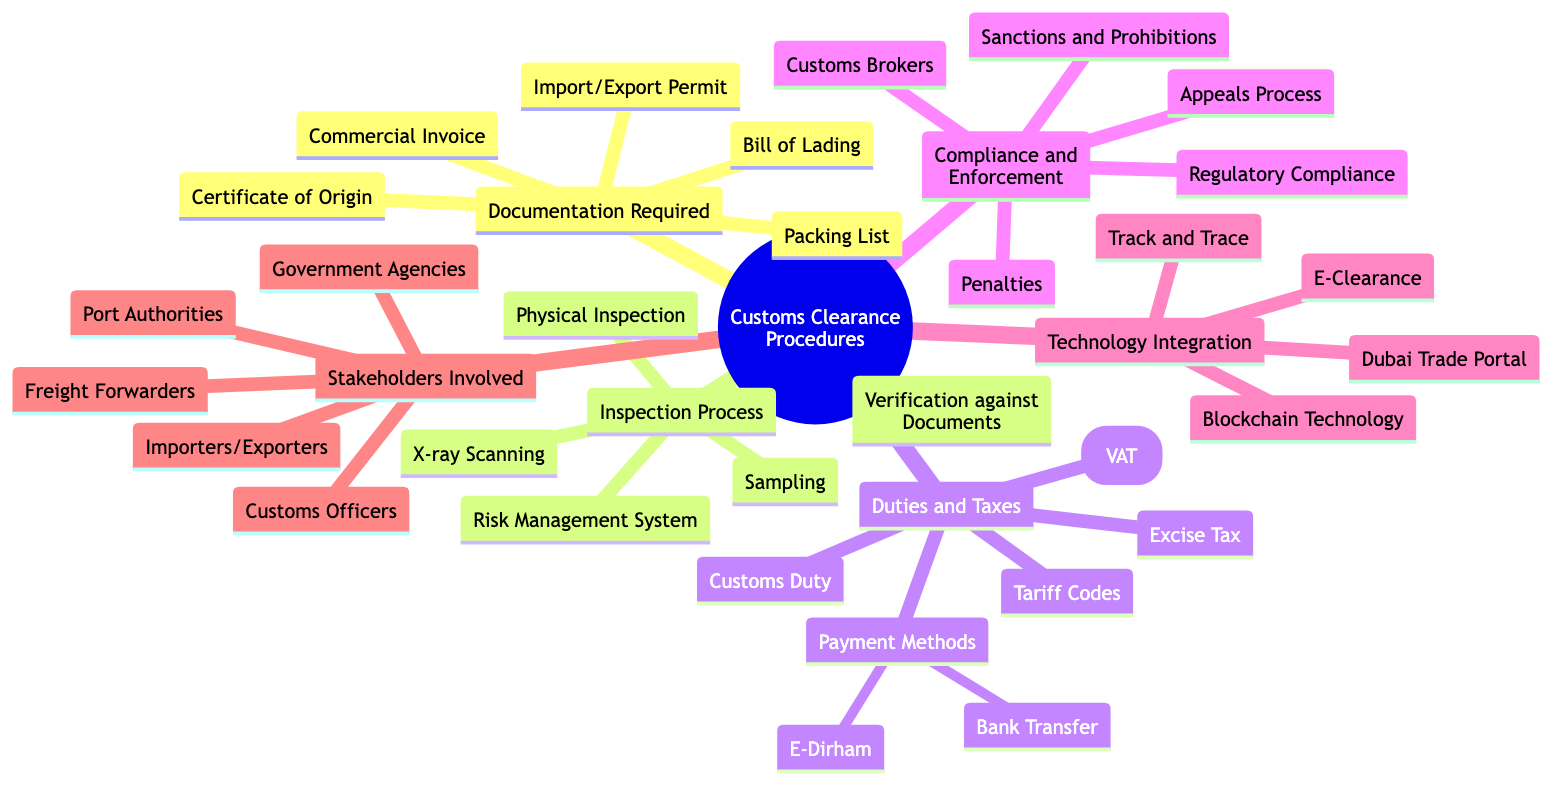What are the components under Documentation Required? The diagram lists the components under Documentation Required as Commercial Invoice, Bill of Lading, Certificate of Origin, Import/Export Permit, and Packing List. These are the key documents needed for customs clearance.
Answer: Commercial Invoice, Bill of Lading, Certificate of Origin, Import/Export Permit, Packing List How many types of inspections are listed? The Inspection Process section contains five types of inspections: Physical Inspection, X-ray Scanning, Risk Management System, Sampling, and Verification against Documents. Thus, the total count of inspection types is five.
Answer: 5 Which tax is imposed on imports by the UAE government? The diagram lists Customs Duty as the tax imposed on imports by the UAE government within the Duties and Taxes section. This is a direct reference from the diagram.
Answer: Customs Duty What is the VAT percentage applicable for goods imported into the UAE? According to the diagram, the Value Added Tax (VAT) is noted as a 5% tax on goods imported into the UAE. Therefore, the VAT percentage is explicitly stated.
Answer: 5% Who is responsible for inspection and clearance? The Stakeholders Involved section identifies Customs Officers as the ones responsible for inspection and clearance, directly stating their role based on the diagram's content.
Answer: Customs Officers What document certifies the country of origin of the imported goods? The Certificate of Origin is specifically mentioned in the Documentation Required section as the document that certifies the country of origin of the imported goods. Thus, the answer directly comes from the diagram.
Answer: Certificate of Origin How many payment methods are there for customs duties? In the Duties and Taxes section, under Payment Methods, two payment options are listed: Bank Transfer and E-Dirham. Therefore, the total number of payment methods is two.
Answer: 2 What system is used to identify high-risk shipments? The Risk Management System is mentioned in the Inspection Process section as the system used to identify high-risk shipments, indicating it plays a critical role in the inspection procedure.
Answer: Risk Management System What online platform is referenced for trade and customs services? The Dubai Trade Portal is listed in the Technology Integration section as the online platform for trade and customs services, denoting an important technological tool for customs.
Answer: Dubai Trade Portal 